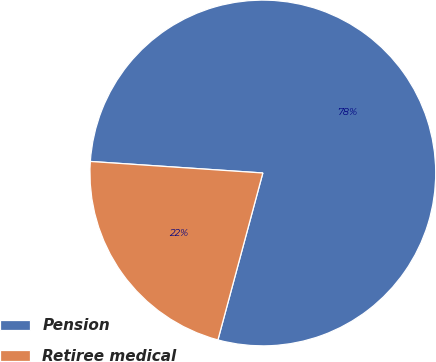Convert chart to OTSL. <chart><loc_0><loc_0><loc_500><loc_500><pie_chart><fcel>Pension<fcel>Retiree medical<nl><fcel>78.12%<fcel>21.88%<nl></chart> 